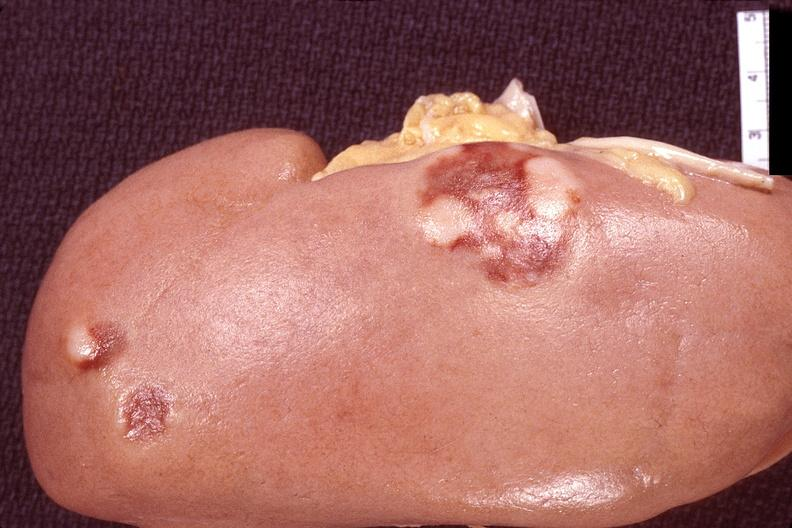what does this image show?
Answer the question using a single word or phrase. Kidney 